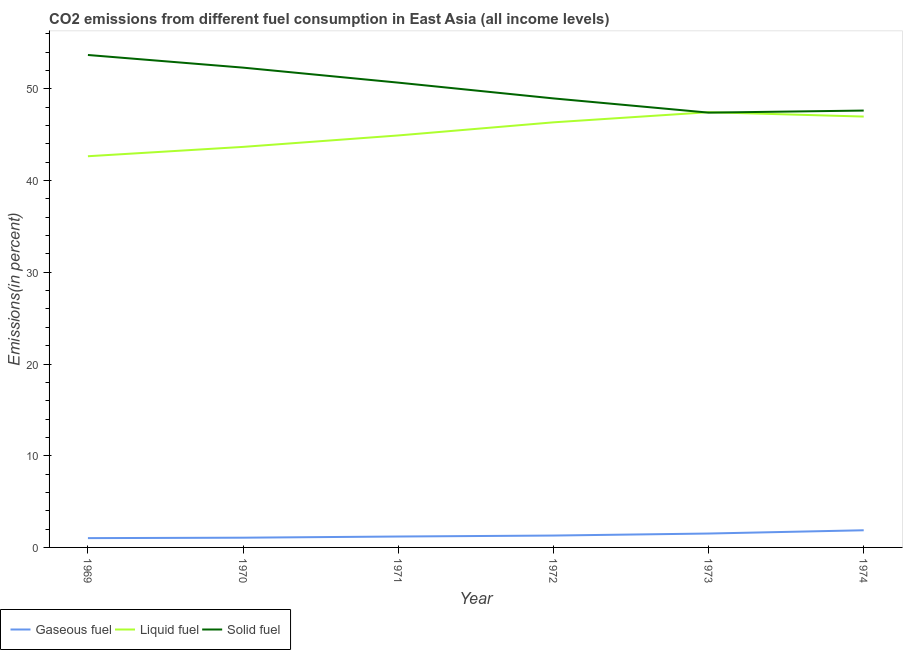How many different coloured lines are there?
Offer a terse response. 3. Does the line corresponding to percentage of solid fuel emission intersect with the line corresponding to percentage of gaseous fuel emission?
Make the answer very short. No. What is the percentage of liquid fuel emission in 1973?
Offer a terse response. 47.46. Across all years, what is the maximum percentage of gaseous fuel emission?
Offer a terse response. 1.87. Across all years, what is the minimum percentage of liquid fuel emission?
Your answer should be compact. 42.66. In which year was the percentage of gaseous fuel emission maximum?
Give a very brief answer. 1974. In which year was the percentage of liquid fuel emission minimum?
Your answer should be compact. 1969. What is the total percentage of liquid fuel emission in the graph?
Your answer should be compact. 272.05. What is the difference between the percentage of gaseous fuel emission in 1969 and that in 1972?
Keep it short and to the point. -0.28. What is the difference between the percentage of gaseous fuel emission in 1973 and the percentage of solid fuel emission in 1972?
Keep it short and to the point. -47.45. What is the average percentage of solid fuel emission per year?
Give a very brief answer. 50.12. In the year 1970, what is the difference between the percentage of liquid fuel emission and percentage of solid fuel emission?
Offer a very short reply. -8.64. What is the ratio of the percentage of gaseous fuel emission in 1973 to that in 1974?
Offer a terse response. 0.81. Is the difference between the percentage of liquid fuel emission in 1970 and 1974 greater than the difference between the percentage of gaseous fuel emission in 1970 and 1974?
Your response must be concise. No. What is the difference between the highest and the second highest percentage of solid fuel emission?
Your answer should be compact. 1.38. What is the difference between the highest and the lowest percentage of solid fuel emission?
Your response must be concise. 6.29. In how many years, is the percentage of liquid fuel emission greater than the average percentage of liquid fuel emission taken over all years?
Give a very brief answer. 3. Is the sum of the percentage of gaseous fuel emission in 1969 and 1970 greater than the maximum percentage of solid fuel emission across all years?
Make the answer very short. No. Is it the case that in every year, the sum of the percentage of gaseous fuel emission and percentage of liquid fuel emission is greater than the percentage of solid fuel emission?
Provide a succinct answer. No. How many years are there in the graph?
Offer a very short reply. 6. Does the graph contain any zero values?
Offer a terse response. No. Where does the legend appear in the graph?
Ensure brevity in your answer.  Bottom left. How many legend labels are there?
Give a very brief answer. 3. How are the legend labels stacked?
Your answer should be compact. Horizontal. What is the title of the graph?
Provide a succinct answer. CO2 emissions from different fuel consumption in East Asia (all income levels). What is the label or title of the Y-axis?
Ensure brevity in your answer.  Emissions(in percent). What is the Emissions(in percent) in Gaseous fuel in 1969?
Ensure brevity in your answer.  1.01. What is the Emissions(in percent) of Liquid fuel in 1969?
Your answer should be very brief. 42.66. What is the Emissions(in percent) of Solid fuel in 1969?
Make the answer very short. 53.7. What is the Emissions(in percent) in Gaseous fuel in 1970?
Make the answer very short. 1.06. What is the Emissions(in percent) in Liquid fuel in 1970?
Offer a very short reply. 43.68. What is the Emissions(in percent) of Solid fuel in 1970?
Ensure brevity in your answer.  52.32. What is the Emissions(in percent) of Gaseous fuel in 1971?
Ensure brevity in your answer.  1.19. What is the Emissions(in percent) in Liquid fuel in 1971?
Make the answer very short. 44.92. What is the Emissions(in percent) of Solid fuel in 1971?
Make the answer very short. 50.68. What is the Emissions(in percent) of Gaseous fuel in 1972?
Your answer should be very brief. 1.3. What is the Emissions(in percent) of Liquid fuel in 1972?
Your response must be concise. 46.35. What is the Emissions(in percent) in Solid fuel in 1972?
Your answer should be very brief. 48.96. What is the Emissions(in percent) of Gaseous fuel in 1973?
Provide a succinct answer. 1.52. What is the Emissions(in percent) in Liquid fuel in 1973?
Keep it short and to the point. 47.46. What is the Emissions(in percent) of Solid fuel in 1973?
Offer a very short reply. 47.41. What is the Emissions(in percent) in Gaseous fuel in 1974?
Ensure brevity in your answer.  1.87. What is the Emissions(in percent) of Liquid fuel in 1974?
Your answer should be very brief. 46.98. What is the Emissions(in percent) in Solid fuel in 1974?
Your response must be concise. 47.64. Across all years, what is the maximum Emissions(in percent) in Gaseous fuel?
Offer a very short reply. 1.87. Across all years, what is the maximum Emissions(in percent) in Liquid fuel?
Make the answer very short. 47.46. Across all years, what is the maximum Emissions(in percent) of Solid fuel?
Your answer should be compact. 53.7. Across all years, what is the minimum Emissions(in percent) of Gaseous fuel?
Offer a very short reply. 1.01. Across all years, what is the minimum Emissions(in percent) in Liquid fuel?
Offer a very short reply. 42.66. Across all years, what is the minimum Emissions(in percent) in Solid fuel?
Keep it short and to the point. 47.41. What is the total Emissions(in percent) in Gaseous fuel in the graph?
Keep it short and to the point. 7.95. What is the total Emissions(in percent) of Liquid fuel in the graph?
Your response must be concise. 272.05. What is the total Emissions(in percent) of Solid fuel in the graph?
Your answer should be very brief. 300.71. What is the difference between the Emissions(in percent) in Gaseous fuel in 1969 and that in 1970?
Your response must be concise. -0.05. What is the difference between the Emissions(in percent) of Liquid fuel in 1969 and that in 1970?
Provide a succinct answer. -1.02. What is the difference between the Emissions(in percent) of Solid fuel in 1969 and that in 1970?
Your answer should be compact. 1.38. What is the difference between the Emissions(in percent) of Gaseous fuel in 1969 and that in 1971?
Offer a very short reply. -0.18. What is the difference between the Emissions(in percent) of Liquid fuel in 1969 and that in 1971?
Make the answer very short. -2.27. What is the difference between the Emissions(in percent) in Solid fuel in 1969 and that in 1971?
Offer a terse response. 3.01. What is the difference between the Emissions(in percent) in Gaseous fuel in 1969 and that in 1972?
Provide a succinct answer. -0.28. What is the difference between the Emissions(in percent) of Liquid fuel in 1969 and that in 1972?
Your answer should be compact. -3.7. What is the difference between the Emissions(in percent) in Solid fuel in 1969 and that in 1972?
Provide a succinct answer. 4.74. What is the difference between the Emissions(in percent) in Gaseous fuel in 1969 and that in 1973?
Your answer should be very brief. -0.5. What is the difference between the Emissions(in percent) in Liquid fuel in 1969 and that in 1973?
Provide a short and direct response. -4.8. What is the difference between the Emissions(in percent) of Solid fuel in 1969 and that in 1973?
Your response must be concise. 6.29. What is the difference between the Emissions(in percent) in Gaseous fuel in 1969 and that in 1974?
Ensure brevity in your answer.  -0.86. What is the difference between the Emissions(in percent) in Liquid fuel in 1969 and that in 1974?
Keep it short and to the point. -4.33. What is the difference between the Emissions(in percent) in Solid fuel in 1969 and that in 1974?
Offer a terse response. 6.06. What is the difference between the Emissions(in percent) in Gaseous fuel in 1970 and that in 1971?
Provide a short and direct response. -0.13. What is the difference between the Emissions(in percent) of Liquid fuel in 1970 and that in 1971?
Offer a very short reply. -1.25. What is the difference between the Emissions(in percent) of Solid fuel in 1970 and that in 1971?
Make the answer very short. 1.64. What is the difference between the Emissions(in percent) of Gaseous fuel in 1970 and that in 1972?
Offer a very short reply. -0.23. What is the difference between the Emissions(in percent) of Liquid fuel in 1970 and that in 1972?
Offer a very short reply. -2.68. What is the difference between the Emissions(in percent) in Solid fuel in 1970 and that in 1972?
Keep it short and to the point. 3.36. What is the difference between the Emissions(in percent) in Gaseous fuel in 1970 and that in 1973?
Give a very brief answer. -0.45. What is the difference between the Emissions(in percent) in Liquid fuel in 1970 and that in 1973?
Offer a terse response. -3.78. What is the difference between the Emissions(in percent) of Solid fuel in 1970 and that in 1973?
Ensure brevity in your answer.  4.91. What is the difference between the Emissions(in percent) in Gaseous fuel in 1970 and that in 1974?
Offer a terse response. -0.81. What is the difference between the Emissions(in percent) in Liquid fuel in 1970 and that in 1974?
Your answer should be compact. -3.31. What is the difference between the Emissions(in percent) in Solid fuel in 1970 and that in 1974?
Provide a short and direct response. 4.68. What is the difference between the Emissions(in percent) of Gaseous fuel in 1971 and that in 1972?
Offer a very short reply. -0.11. What is the difference between the Emissions(in percent) in Liquid fuel in 1971 and that in 1972?
Offer a very short reply. -1.43. What is the difference between the Emissions(in percent) in Solid fuel in 1971 and that in 1972?
Offer a very short reply. 1.72. What is the difference between the Emissions(in percent) of Gaseous fuel in 1971 and that in 1973?
Provide a succinct answer. -0.33. What is the difference between the Emissions(in percent) of Liquid fuel in 1971 and that in 1973?
Provide a short and direct response. -2.53. What is the difference between the Emissions(in percent) of Solid fuel in 1971 and that in 1973?
Keep it short and to the point. 3.27. What is the difference between the Emissions(in percent) of Gaseous fuel in 1971 and that in 1974?
Your answer should be very brief. -0.68. What is the difference between the Emissions(in percent) in Liquid fuel in 1971 and that in 1974?
Provide a succinct answer. -2.06. What is the difference between the Emissions(in percent) in Solid fuel in 1971 and that in 1974?
Your response must be concise. 3.05. What is the difference between the Emissions(in percent) of Gaseous fuel in 1972 and that in 1973?
Your response must be concise. -0.22. What is the difference between the Emissions(in percent) of Liquid fuel in 1972 and that in 1973?
Provide a short and direct response. -1.1. What is the difference between the Emissions(in percent) of Solid fuel in 1972 and that in 1973?
Your answer should be compact. 1.55. What is the difference between the Emissions(in percent) of Gaseous fuel in 1972 and that in 1974?
Your answer should be compact. -0.57. What is the difference between the Emissions(in percent) in Liquid fuel in 1972 and that in 1974?
Your answer should be compact. -0.63. What is the difference between the Emissions(in percent) of Solid fuel in 1972 and that in 1974?
Make the answer very short. 1.33. What is the difference between the Emissions(in percent) of Gaseous fuel in 1973 and that in 1974?
Make the answer very short. -0.36. What is the difference between the Emissions(in percent) of Liquid fuel in 1973 and that in 1974?
Offer a very short reply. 0.48. What is the difference between the Emissions(in percent) in Solid fuel in 1973 and that in 1974?
Provide a short and direct response. -0.23. What is the difference between the Emissions(in percent) of Gaseous fuel in 1969 and the Emissions(in percent) of Liquid fuel in 1970?
Your answer should be compact. -42.66. What is the difference between the Emissions(in percent) in Gaseous fuel in 1969 and the Emissions(in percent) in Solid fuel in 1970?
Offer a very short reply. -51.3. What is the difference between the Emissions(in percent) in Liquid fuel in 1969 and the Emissions(in percent) in Solid fuel in 1970?
Provide a short and direct response. -9.66. What is the difference between the Emissions(in percent) of Gaseous fuel in 1969 and the Emissions(in percent) of Liquid fuel in 1971?
Give a very brief answer. -43.91. What is the difference between the Emissions(in percent) of Gaseous fuel in 1969 and the Emissions(in percent) of Solid fuel in 1971?
Ensure brevity in your answer.  -49.67. What is the difference between the Emissions(in percent) in Liquid fuel in 1969 and the Emissions(in percent) in Solid fuel in 1971?
Make the answer very short. -8.03. What is the difference between the Emissions(in percent) of Gaseous fuel in 1969 and the Emissions(in percent) of Liquid fuel in 1972?
Provide a short and direct response. -45.34. What is the difference between the Emissions(in percent) of Gaseous fuel in 1969 and the Emissions(in percent) of Solid fuel in 1972?
Keep it short and to the point. -47.95. What is the difference between the Emissions(in percent) in Liquid fuel in 1969 and the Emissions(in percent) in Solid fuel in 1972?
Your answer should be very brief. -6.31. What is the difference between the Emissions(in percent) in Gaseous fuel in 1969 and the Emissions(in percent) in Liquid fuel in 1973?
Offer a terse response. -46.44. What is the difference between the Emissions(in percent) in Gaseous fuel in 1969 and the Emissions(in percent) in Solid fuel in 1973?
Give a very brief answer. -46.4. What is the difference between the Emissions(in percent) in Liquid fuel in 1969 and the Emissions(in percent) in Solid fuel in 1973?
Offer a terse response. -4.75. What is the difference between the Emissions(in percent) of Gaseous fuel in 1969 and the Emissions(in percent) of Liquid fuel in 1974?
Give a very brief answer. -45.97. What is the difference between the Emissions(in percent) in Gaseous fuel in 1969 and the Emissions(in percent) in Solid fuel in 1974?
Make the answer very short. -46.62. What is the difference between the Emissions(in percent) of Liquid fuel in 1969 and the Emissions(in percent) of Solid fuel in 1974?
Give a very brief answer. -4.98. What is the difference between the Emissions(in percent) in Gaseous fuel in 1970 and the Emissions(in percent) in Liquid fuel in 1971?
Provide a short and direct response. -43.86. What is the difference between the Emissions(in percent) in Gaseous fuel in 1970 and the Emissions(in percent) in Solid fuel in 1971?
Your response must be concise. -49.62. What is the difference between the Emissions(in percent) of Liquid fuel in 1970 and the Emissions(in percent) of Solid fuel in 1971?
Keep it short and to the point. -7.01. What is the difference between the Emissions(in percent) in Gaseous fuel in 1970 and the Emissions(in percent) in Liquid fuel in 1972?
Your answer should be compact. -45.29. What is the difference between the Emissions(in percent) of Gaseous fuel in 1970 and the Emissions(in percent) of Solid fuel in 1972?
Keep it short and to the point. -47.9. What is the difference between the Emissions(in percent) in Liquid fuel in 1970 and the Emissions(in percent) in Solid fuel in 1972?
Ensure brevity in your answer.  -5.29. What is the difference between the Emissions(in percent) of Gaseous fuel in 1970 and the Emissions(in percent) of Liquid fuel in 1973?
Keep it short and to the point. -46.4. What is the difference between the Emissions(in percent) of Gaseous fuel in 1970 and the Emissions(in percent) of Solid fuel in 1973?
Provide a succinct answer. -46.35. What is the difference between the Emissions(in percent) in Liquid fuel in 1970 and the Emissions(in percent) in Solid fuel in 1973?
Ensure brevity in your answer.  -3.73. What is the difference between the Emissions(in percent) in Gaseous fuel in 1970 and the Emissions(in percent) in Liquid fuel in 1974?
Provide a succinct answer. -45.92. What is the difference between the Emissions(in percent) in Gaseous fuel in 1970 and the Emissions(in percent) in Solid fuel in 1974?
Provide a short and direct response. -46.58. What is the difference between the Emissions(in percent) in Liquid fuel in 1970 and the Emissions(in percent) in Solid fuel in 1974?
Keep it short and to the point. -3.96. What is the difference between the Emissions(in percent) in Gaseous fuel in 1971 and the Emissions(in percent) in Liquid fuel in 1972?
Offer a very short reply. -45.16. What is the difference between the Emissions(in percent) of Gaseous fuel in 1971 and the Emissions(in percent) of Solid fuel in 1972?
Your answer should be compact. -47.77. What is the difference between the Emissions(in percent) of Liquid fuel in 1971 and the Emissions(in percent) of Solid fuel in 1972?
Make the answer very short. -4.04. What is the difference between the Emissions(in percent) in Gaseous fuel in 1971 and the Emissions(in percent) in Liquid fuel in 1973?
Provide a succinct answer. -46.27. What is the difference between the Emissions(in percent) in Gaseous fuel in 1971 and the Emissions(in percent) in Solid fuel in 1973?
Offer a terse response. -46.22. What is the difference between the Emissions(in percent) of Liquid fuel in 1971 and the Emissions(in percent) of Solid fuel in 1973?
Ensure brevity in your answer.  -2.49. What is the difference between the Emissions(in percent) of Gaseous fuel in 1971 and the Emissions(in percent) of Liquid fuel in 1974?
Provide a succinct answer. -45.79. What is the difference between the Emissions(in percent) in Gaseous fuel in 1971 and the Emissions(in percent) in Solid fuel in 1974?
Make the answer very short. -46.45. What is the difference between the Emissions(in percent) in Liquid fuel in 1971 and the Emissions(in percent) in Solid fuel in 1974?
Give a very brief answer. -2.71. What is the difference between the Emissions(in percent) of Gaseous fuel in 1972 and the Emissions(in percent) of Liquid fuel in 1973?
Give a very brief answer. -46.16. What is the difference between the Emissions(in percent) in Gaseous fuel in 1972 and the Emissions(in percent) in Solid fuel in 1973?
Give a very brief answer. -46.12. What is the difference between the Emissions(in percent) in Liquid fuel in 1972 and the Emissions(in percent) in Solid fuel in 1973?
Ensure brevity in your answer.  -1.06. What is the difference between the Emissions(in percent) in Gaseous fuel in 1972 and the Emissions(in percent) in Liquid fuel in 1974?
Give a very brief answer. -45.69. What is the difference between the Emissions(in percent) in Gaseous fuel in 1972 and the Emissions(in percent) in Solid fuel in 1974?
Your answer should be compact. -46.34. What is the difference between the Emissions(in percent) of Liquid fuel in 1972 and the Emissions(in percent) of Solid fuel in 1974?
Keep it short and to the point. -1.28. What is the difference between the Emissions(in percent) of Gaseous fuel in 1973 and the Emissions(in percent) of Liquid fuel in 1974?
Make the answer very short. -45.47. What is the difference between the Emissions(in percent) in Gaseous fuel in 1973 and the Emissions(in percent) in Solid fuel in 1974?
Offer a terse response. -46.12. What is the difference between the Emissions(in percent) in Liquid fuel in 1973 and the Emissions(in percent) in Solid fuel in 1974?
Provide a succinct answer. -0.18. What is the average Emissions(in percent) in Gaseous fuel per year?
Your answer should be very brief. 1.32. What is the average Emissions(in percent) in Liquid fuel per year?
Keep it short and to the point. 45.34. What is the average Emissions(in percent) of Solid fuel per year?
Your response must be concise. 50.12. In the year 1969, what is the difference between the Emissions(in percent) in Gaseous fuel and Emissions(in percent) in Liquid fuel?
Your response must be concise. -41.64. In the year 1969, what is the difference between the Emissions(in percent) in Gaseous fuel and Emissions(in percent) in Solid fuel?
Your answer should be very brief. -52.68. In the year 1969, what is the difference between the Emissions(in percent) in Liquid fuel and Emissions(in percent) in Solid fuel?
Make the answer very short. -11.04. In the year 1970, what is the difference between the Emissions(in percent) in Gaseous fuel and Emissions(in percent) in Liquid fuel?
Provide a short and direct response. -42.62. In the year 1970, what is the difference between the Emissions(in percent) of Gaseous fuel and Emissions(in percent) of Solid fuel?
Provide a short and direct response. -51.26. In the year 1970, what is the difference between the Emissions(in percent) of Liquid fuel and Emissions(in percent) of Solid fuel?
Your response must be concise. -8.64. In the year 1971, what is the difference between the Emissions(in percent) in Gaseous fuel and Emissions(in percent) in Liquid fuel?
Make the answer very short. -43.73. In the year 1971, what is the difference between the Emissions(in percent) in Gaseous fuel and Emissions(in percent) in Solid fuel?
Your response must be concise. -49.49. In the year 1971, what is the difference between the Emissions(in percent) of Liquid fuel and Emissions(in percent) of Solid fuel?
Your response must be concise. -5.76. In the year 1972, what is the difference between the Emissions(in percent) of Gaseous fuel and Emissions(in percent) of Liquid fuel?
Keep it short and to the point. -45.06. In the year 1972, what is the difference between the Emissions(in percent) in Gaseous fuel and Emissions(in percent) in Solid fuel?
Keep it short and to the point. -47.67. In the year 1972, what is the difference between the Emissions(in percent) in Liquid fuel and Emissions(in percent) in Solid fuel?
Offer a terse response. -2.61. In the year 1973, what is the difference between the Emissions(in percent) of Gaseous fuel and Emissions(in percent) of Liquid fuel?
Provide a succinct answer. -45.94. In the year 1973, what is the difference between the Emissions(in percent) of Gaseous fuel and Emissions(in percent) of Solid fuel?
Your response must be concise. -45.9. In the year 1973, what is the difference between the Emissions(in percent) of Liquid fuel and Emissions(in percent) of Solid fuel?
Ensure brevity in your answer.  0.05. In the year 1974, what is the difference between the Emissions(in percent) of Gaseous fuel and Emissions(in percent) of Liquid fuel?
Provide a short and direct response. -45.11. In the year 1974, what is the difference between the Emissions(in percent) in Gaseous fuel and Emissions(in percent) in Solid fuel?
Offer a very short reply. -45.77. In the year 1974, what is the difference between the Emissions(in percent) in Liquid fuel and Emissions(in percent) in Solid fuel?
Your response must be concise. -0.66. What is the ratio of the Emissions(in percent) of Gaseous fuel in 1969 to that in 1970?
Keep it short and to the point. 0.95. What is the ratio of the Emissions(in percent) of Liquid fuel in 1969 to that in 1970?
Your answer should be very brief. 0.98. What is the ratio of the Emissions(in percent) in Solid fuel in 1969 to that in 1970?
Your answer should be compact. 1.03. What is the ratio of the Emissions(in percent) in Gaseous fuel in 1969 to that in 1971?
Your answer should be compact. 0.85. What is the ratio of the Emissions(in percent) of Liquid fuel in 1969 to that in 1971?
Offer a very short reply. 0.95. What is the ratio of the Emissions(in percent) of Solid fuel in 1969 to that in 1971?
Offer a terse response. 1.06. What is the ratio of the Emissions(in percent) of Gaseous fuel in 1969 to that in 1972?
Keep it short and to the point. 0.78. What is the ratio of the Emissions(in percent) in Liquid fuel in 1969 to that in 1972?
Give a very brief answer. 0.92. What is the ratio of the Emissions(in percent) in Solid fuel in 1969 to that in 1972?
Your answer should be compact. 1.1. What is the ratio of the Emissions(in percent) of Gaseous fuel in 1969 to that in 1973?
Offer a terse response. 0.67. What is the ratio of the Emissions(in percent) of Liquid fuel in 1969 to that in 1973?
Give a very brief answer. 0.9. What is the ratio of the Emissions(in percent) of Solid fuel in 1969 to that in 1973?
Your response must be concise. 1.13. What is the ratio of the Emissions(in percent) of Gaseous fuel in 1969 to that in 1974?
Keep it short and to the point. 0.54. What is the ratio of the Emissions(in percent) of Liquid fuel in 1969 to that in 1974?
Offer a very short reply. 0.91. What is the ratio of the Emissions(in percent) of Solid fuel in 1969 to that in 1974?
Keep it short and to the point. 1.13. What is the ratio of the Emissions(in percent) in Gaseous fuel in 1970 to that in 1971?
Provide a short and direct response. 0.89. What is the ratio of the Emissions(in percent) in Liquid fuel in 1970 to that in 1971?
Your response must be concise. 0.97. What is the ratio of the Emissions(in percent) of Solid fuel in 1970 to that in 1971?
Provide a succinct answer. 1.03. What is the ratio of the Emissions(in percent) in Gaseous fuel in 1970 to that in 1972?
Offer a terse response. 0.82. What is the ratio of the Emissions(in percent) of Liquid fuel in 1970 to that in 1972?
Your response must be concise. 0.94. What is the ratio of the Emissions(in percent) of Solid fuel in 1970 to that in 1972?
Your answer should be very brief. 1.07. What is the ratio of the Emissions(in percent) in Gaseous fuel in 1970 to that in 1973?
Provide a short and direct response. 0.7. What is the ratio of the Emissions(in percent) in Liquid fuel in 1970 to that in 1973?
Make the answer very short. 0.92. What is the ratio of the Emissions(in percent) of Solid fuel in 1970 to that in 1973?
Keep it short and to the point. 1.1. What is the ratio of the Emissions(in percent) of Gaseous fuel in 1970 to that in 1974?
Keep it short and to the point. 0.57. What is the ratio of the Emissions(in percent) in Liquid fuel in 1970 to that in 1974?
Provide a succinct answer. 0.93. What is the ratio of the Emissions(in percent) in Solid fuel in 1970 to that in 1974?
Give a very brief answer. 1.1. What is the ratio of the Emissions(in percent) of Gaseous fuel in 1971 to that in 1972?
Your answer should be very brief. 0.92. What is the ratio of the Emissions(in percent) of Liquid fuel in 1971 to that in 1972?
Keep it short and to the point. 0.97. What is the ratio of the Emissions(in percent) in Solid fuel in 1971 to that in 1972?
Offer a very short reply. 1.04. What is the ratio of the Emissions(in percent) of Gaseous fuel in 1971 to that in 1973?
Make the answer very short. 0.78. What is the ratio of the Emissions(in percent) in Liquid fuel in 1971 to that in 1973?
Give a very brief answer. 0.95. What is the ratio of the Emissions(in percent) in Solid fuel in 1971 to that in 1973?
Make the answer very short. 1.07. What is the ratio of the Emissions(in percent) of Gaseous fuel in 1971 to that in 1974?
Give a very brief answer. 0.64. What is the ratio of the Emissions(in percent) of Liquid fuel in 1971 to that in 1974?
Your answer should be very brief. 0.96. What is the ratio of the Emissions(in percent) of Solid fuel in 1971 to that in 1974?
Keep it short and to the point. 1.06. What is the ratio of the Emissions(in percent) in Gaseous fuel in 1972 to that in 1973?
Make the answer very short. 0.86. What is the ratio of the Emissions(in percent) of Liquid fuel in 1972 to that in 1973?
Your answer should be compact. 0.98. What is the ratio of the Emissions(in percent) of Solid fuel in 1972 to that in 1973?
Make the answer very short. 1.03. What is the ratio of the Emissions(in percent) of Gaseous fuel in 1972 to that in 1974?
Your response must be concise. 0.69. What is the ratio of the Emissions(in percent) in Liquid fuel in 1972 to that in 1974?
Ensure brevity in your answer.  0.99. What is the ratio of the Emissions(in percent) of Solid fuel in 1972 to that in 1974?
Keep it short and to the point. 1.03. What is the ratio of the Emissions(in percent) of Gaseous fuel in 1973 to that in 1974?
Offer a very short reply. 0.81. What is the ratio of the Emissions(in percent) in Liquid fuel in 1973 to that in 1974?
Give a very brief answer. 1.01. What is the ratio of the Emissions(in percent) in Solid fuel in 1973 to that in 1974?
Your response must be concise. 1. What is the difference between the highest and the second highest Emissions(in percent) in Gaseous fuel?
Your answer should be very brief. 0.36. What is the difference between the highest and the second highest Emissions(in percent) in Liquid fuel?
Offer a terse response. 0.48. What is the difference between the highest and the second highest Emissions(in percent) of Solid fuel?
Provide a succinct answer. 1.38. What is the difference between the highest and the lowest Emissions(in percent) in Gaseous fuel?
Your answer should be compact. 0.86. What is the difference between the highest and the lowest Emissions(in percent) of Liquid fuel?
Offer a very short reply. 4.8. What is the difference between the highest and the lowest Emissions(in percent) of Solid fuel?
Your response must be concise. 6.29. 